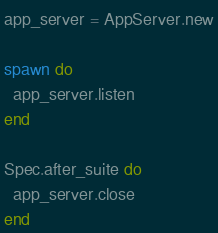<code> <loc_0><loc_0><loc_500><loc_500><_Crystal_>app_server = AppServer.new

spawn do
  app_server.listen
end

Spec.after_suite do
  app_server.close
end
</code> 